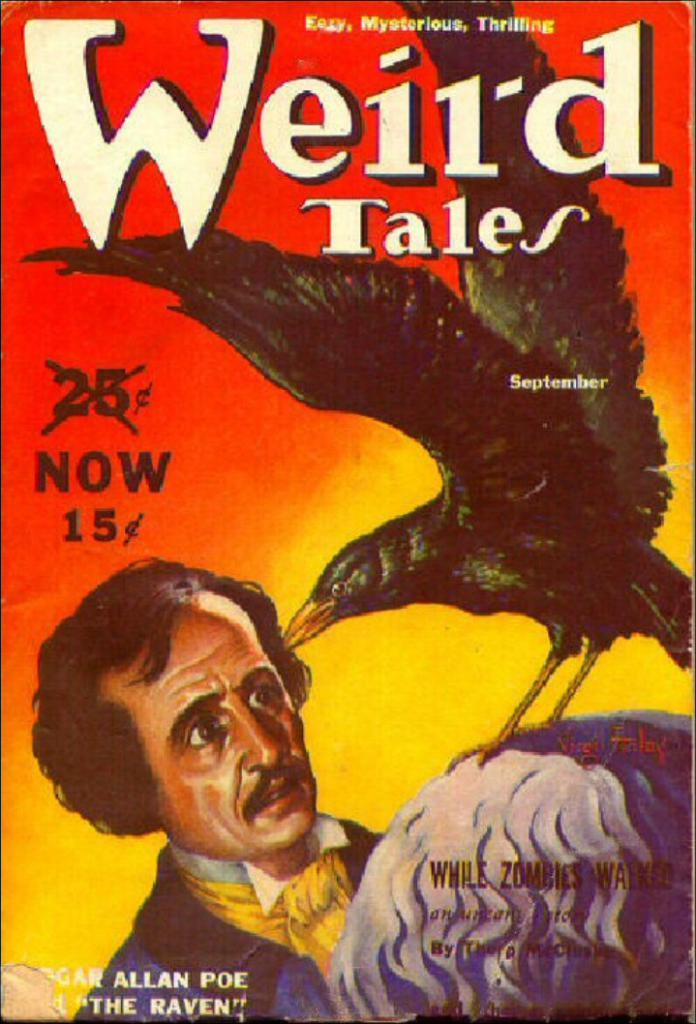<image>
Give a short and clear explanation of the subsequent image. a book that has the title of weird tales 